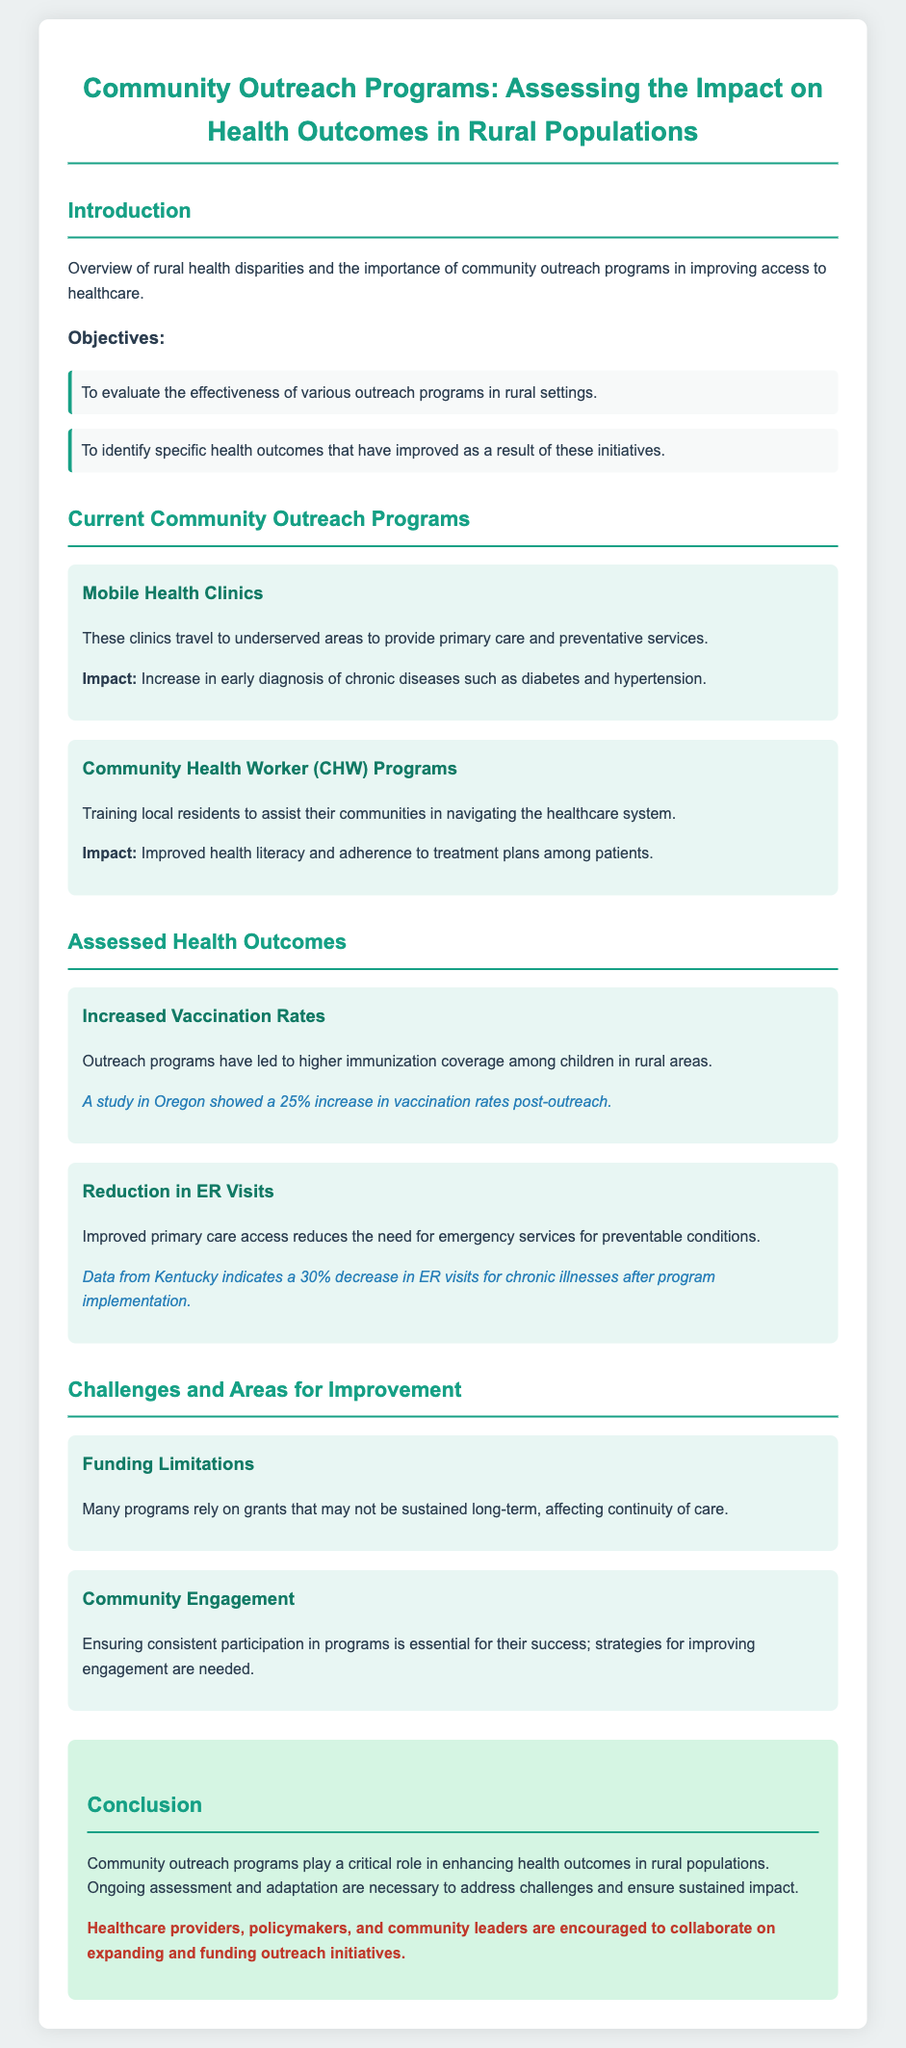What is the main focus of community outreach programs discussed? The document discusses the impact of community outreach programs on health outcomes in rural populations.
Answer: health outcomes in rural populations What are the two main objectives of the outreach programs? The objectives include evaluating the effectiveness of various outreach programs and identifying specific improved health outcomes.
Answer: effectiveness of outreach programs and improved health outcomes What percentage increase in vaccination rates was noted post-outreach in Oregon? A study in Oregon showed a 25% increase in vaccination rates after the outreach program implementation.
Answer: 25% What is a consequence of improved primary care access according to the document? The document states that improved primary care access reduces the need for emergency services for preventable conditions.
Answer: reduction in ER visits What challenge regarding program funding is mentioned? The document highlights that many programs rely on grants which may not be sustained long-term, affecting continuity of care.
Answer: Funding Limitations What type of programs is mentioned that involve training local residents? The document refers to Community Health Worker (CHW) programs that train local residents.
Answer: Community Health Worker (CHW) Programs What was the percentage decrease in ER visits reported from Kentucky after program implementation? Data from Kentucky indicates a 30% decrease in ER visits for chronic illnesses after the program implementation.
Answer: 30% What is emphasized as critical for the success of outreach programs? The document emphasizes that ensuring consistent participation in programs is essential for their success.
Answer: Community Engagement 